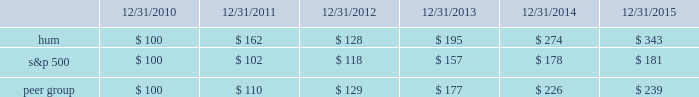Declaration and payment of future quarterly dividends is at the discretion of our board and may be adjusted as business needs or market conditions change .
In addition , under the terms of the merger agreement , we have agreed with aetna to coordinate the declaration and payment of dividends so that our stockholders do not fail to receive a quarterly dividend around the time of the closing of the merger .
On october 29 , 2015 , the board declared a cash dividend of $ 0.29 per share that was paid on january 29 , 2016 to stockholders of record on december 30 , 2015 , for an aggregate amount of $ 43 million .
Stock total return performance the following graph compares our total return to stockholders with the returns of the standard & poor 2019s composite 500 index ( 201cs&p 500 201d ) and the dow jones us select health care providers index ( 201cpeer group 201d ) for the five years ended december 31 , 2015 .
The graph assumes an investment of $ 100 in each of our common stock , the s&p 500 , and the peer group on december 31 , 2010 , and that dividends were reinvested when paid. .
The stock price performance included in this graph is not necessarily indicative of future stock price performance. .
As of december 30 , what was the number of stockholders of record 2015 in millions? 
Computations: (43 / 0.29)
Answer: 148.27586. 